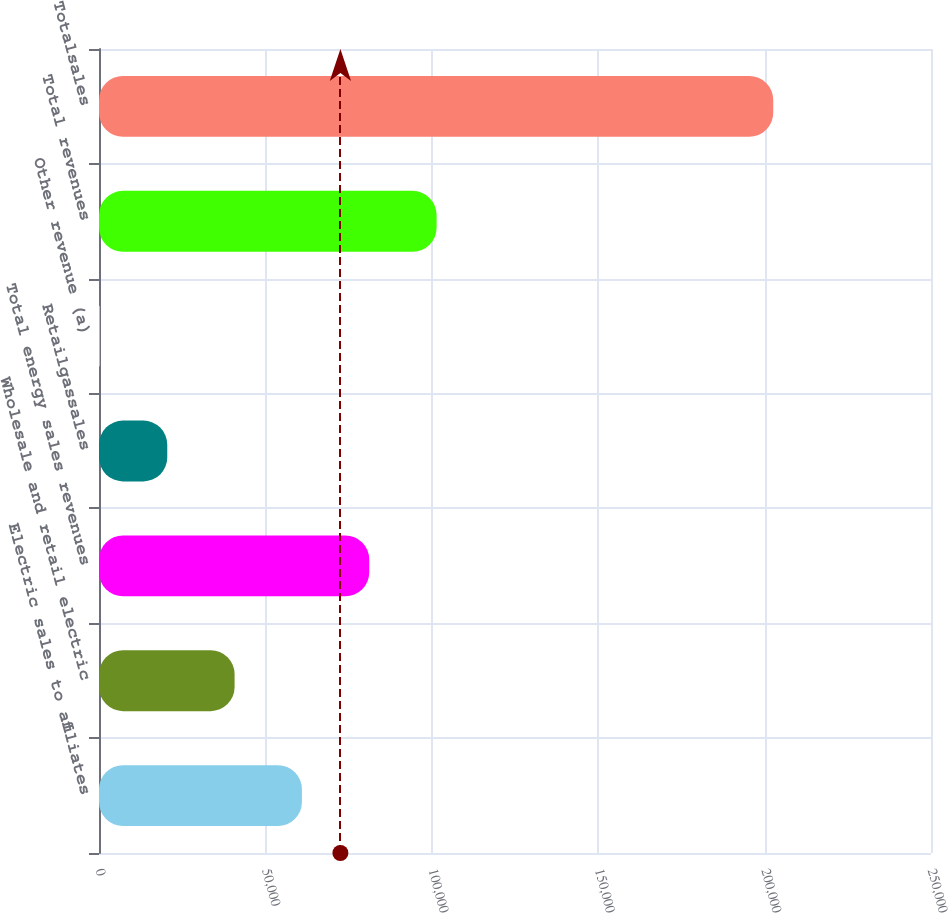Convert chart. <chart><loc_0><loc_0><loc_500><loc_500><bar_chart><fcel>Electric sales to affiliates<fcel>Wholesale and retail electric<fcel>Total energy sales revenues<fcel>Retailgassales<fcel>Other revenue (a)<fcel>Total revenues<fcel>Totalsales<nl><fcel>60975<fcel>40743<fcel>81207<fcel>20511<fcel>279<fcel>101439<fcel>202599<nl></chart> 